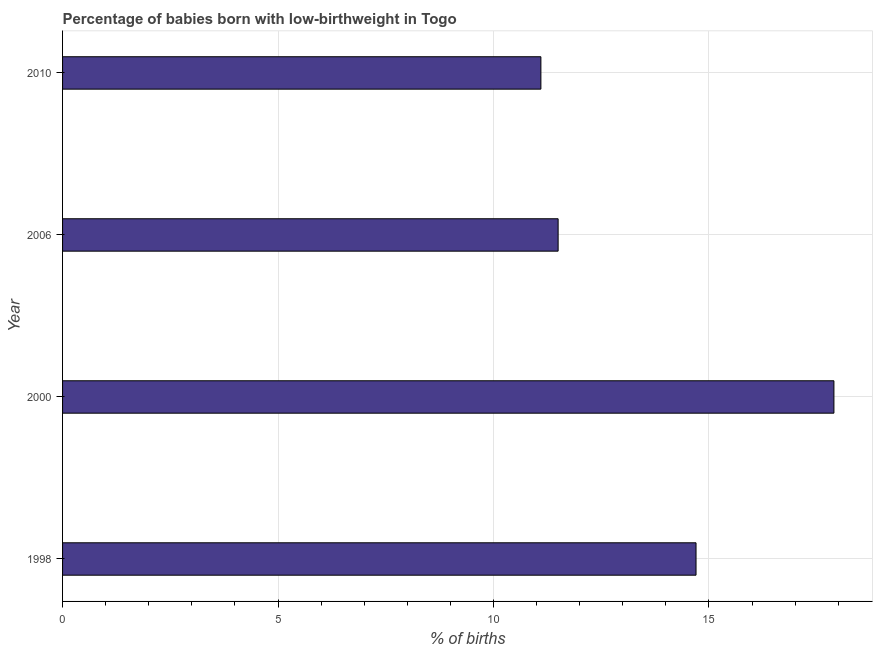Does the graph contain grids?
Your answer should be very brief. Yes. What is the title of the graph?
Give a very brief answer. Percentage of babies born with low-birthweight in Togo. What is the label or title of the X-axis?
Keep it short and to the point. % of births. Across all years, what is the maximum percentage of babies who were born with low-birthweight?
Ensure brevity in your answer.  17.9. In which year was the percentage of babies who were born with low-birthweight maximum?
Give a very brief answer. 2000. In which year was the percentage of babies who were born with low-birthweight minimum?
Your response must be concise. 2010. What is the sum of the percentage of babies who were born with low-birthweight?
Provide a short and direct response. 55.2. What is the average percentage of babies who were born with low-birthweight per year?
Your answer should be very brief. 13.8. What is the median percentage of babies who were born with low-birthweight?
Keep it short and to the point. 13.1. What is the ratio of the percentage of babies who were born with low-birthweight in 1998 to that in 2010?
Your answer should be compact. 1.32. Is the percentage of babies who were born with low-birthweight in 1998 less than that in 2010?
Ensure brevity in your answer.  No. What is the difference between the highest and the second highest percentage of babies who were born with low-birthweight?
Provide a succinct answer. 3.2. Is the sum of the percentage of babies who were born with low-birthweight in 1998 and 2000 greater than the maximum percentage of babies who were born with low-birthweight across all years?
Your answer should be compact. Yes. What is the difference between the highest and the lowest percentage of babies who were born with low-birthweight?
Offer a very short reply. 6.8. What is the difference between two consecutive major ticks on the X-axis?
Your answer should be very brief. 5. Are the values on the major ticks of X-axis written in scientific E-notation?
Keep it short and to the point. No. What is the % of births in 1998?
Offer a terse response. 14.7. What is the % of births in 2000?
Your answer should be compact. 17.9. What is the difference between the % of births in 1998 and 2000?
Provide a succinct answer. -3.2. What is the difference between the % of births in 1998 and 2006?
Ensure brevity in your answer.  3.2. What is the difference between the % of births in 2000 and 2006?
Keep it short and to the point. 6.4. What is the difference between the % of births in 2000 and 2010?
Make the answer very short. 6.8. What is the ratio of the % of births in 1998 to that in 2000?
Give a very brief answer. 0.82. What is the ratio of the % of births in 1998 to that in 2006?
Make the answer very short. 1.28. What is the ratio of the % of births in 1998 to that in 2010?
Provide a short and direct response. 1.32. What is the ratio of the % of births in 2000 to that in 2006?
Offer a very short reply. 1.56. What is the ratio of the % of births in 2000 to that in 2010?
Make the answer very short. 1.61. What is the ratio of the % of births in 2006 to that in 2010?
Make the answer very short. 1.04. 